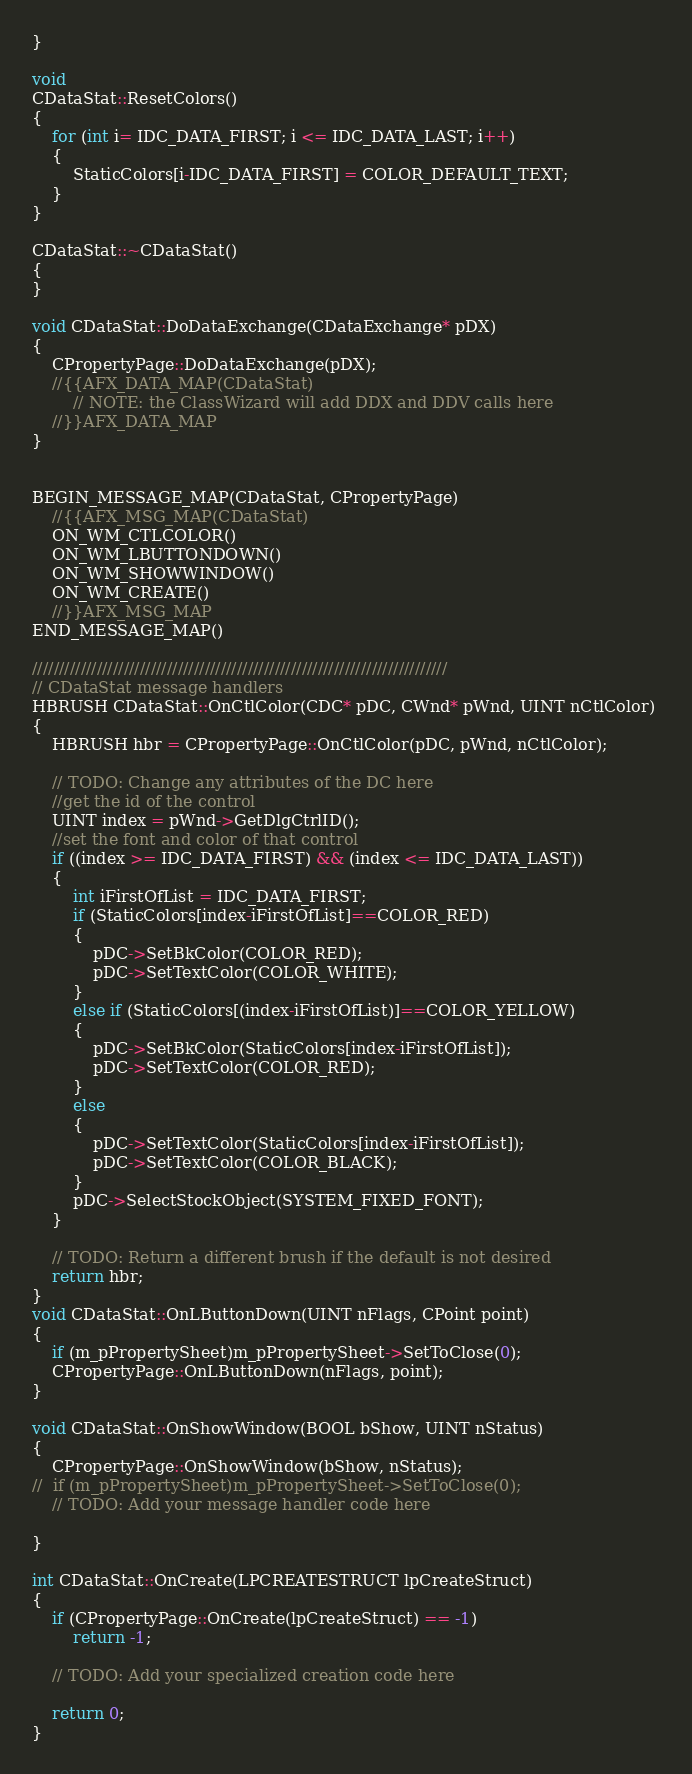<code> <loc_0><loc_0><loc_500><loc_500><_C++_>}

void
CDataStat::ResetColors()
{
	for (int i= IDC_DATA_FIRST; i <= IDC_DATA_LAST; i++)
	{
		StaticColors[i-IDC_DATA_FIRST] = COLOR_DEFAULT_TEXT;
	}
}

CDataStat::~CDataStat()
{
}

void CDataStat::DoDataExchange(CDataExchange* pDX)
{
	CPropertyPage::DoDataExchange(pDX);
	//{{AFX_DATA_MAP(CDataStat)
		// NOTE: the ClassWizard will add DDX and DDV calls here
	//}}AFX_DATA_MAP
}


BEGIN_MESSAGE_MAP(CDataStat, CPropertyPage)
	//{{AFX_MSG_MAP(CDataStat)
	ON_WM_CTLCOLOR()
	ON_WM_LBUTTONDOWN()
	ON_WM_SHOWWINDOW()
	ON_WM_CREATE()
	//}}AFX_MSG_MAP
END_MESSAGE_MAP()

/////////////////////////////////////////////////////////////////////////////
// CDataStat message handlers
HBRUSH CDataStat::OnCtlColor(CDC* pDC, CWnd* pWnd, UINT nCtlColor) 
{
	HBRUSH hbr = CPropertyPage::OnCtlColor(pDC, pWnd, nCtlColor);
	
	// TODO: Change any attributes of the DC here
	//get the id of the control 
	UINT index = pWnd->GetDlgCtrlID();
	//set the font and color of that control
	if ((index >= IDC_DATA_FIRST) && (index <= IDC_DATA_LAST))
	{
		int iFirstOfList = IDC_DATA_FIRST; 
		if (StaticColors[index-iFirstOfList]==COLOR_RED)
		{
			pDC->SetBkColor(COLOR_RED);
			pDC->SetTextColor(COLOR_WHITE);
		}
		else if (StaticColors[(index-iFirstOfList)]==COLOR_YELLOW)
		{
			pDC->SetBkColor(StaticColors[index-iFirstOfList]);
			pDC->SetTextColor(COLOR_RED);
		}
		else
		{
			pDC->SetTextColor(StaticColors[index-iFirstOfList]);
			pDC->SetTextColor(COLOR_BLACK);
		}
		pDC->SelectStockObject(SYSTEM_FIXED_FONT);
	}

	// TODO: Return a different brush if the default is not desired
	return hbr;
}
void CDataStat::OnLButtonDown(UINT nFlags, CPoint point) 
{
	if (m_pPropertySheet)m_pPropertySheet->SetToClose(0);
	CPropertyPage::OnLButtonDown(nFlags, point);
}

void CDataStat::OnShowWindow(BOOL bShow, UINT nStatus) 
{
	CPropertyPage::OnShowWindow(bShow, nStatus);
//	if (m_pPropertySheet)m_pPropertySheet->SetToClose(0);
	// TODO: Add your message handler code here
	
}

int CDataStat::OnCreate(LPCREATESTRUCT lpCreateStruct) 
{
	if (CPropertyPage::OnCreate(lpCreateStruct) == -1)
		return -1;
	
	// TODO: Add your specialized creation code here
	
	return 0;
}
</code> 